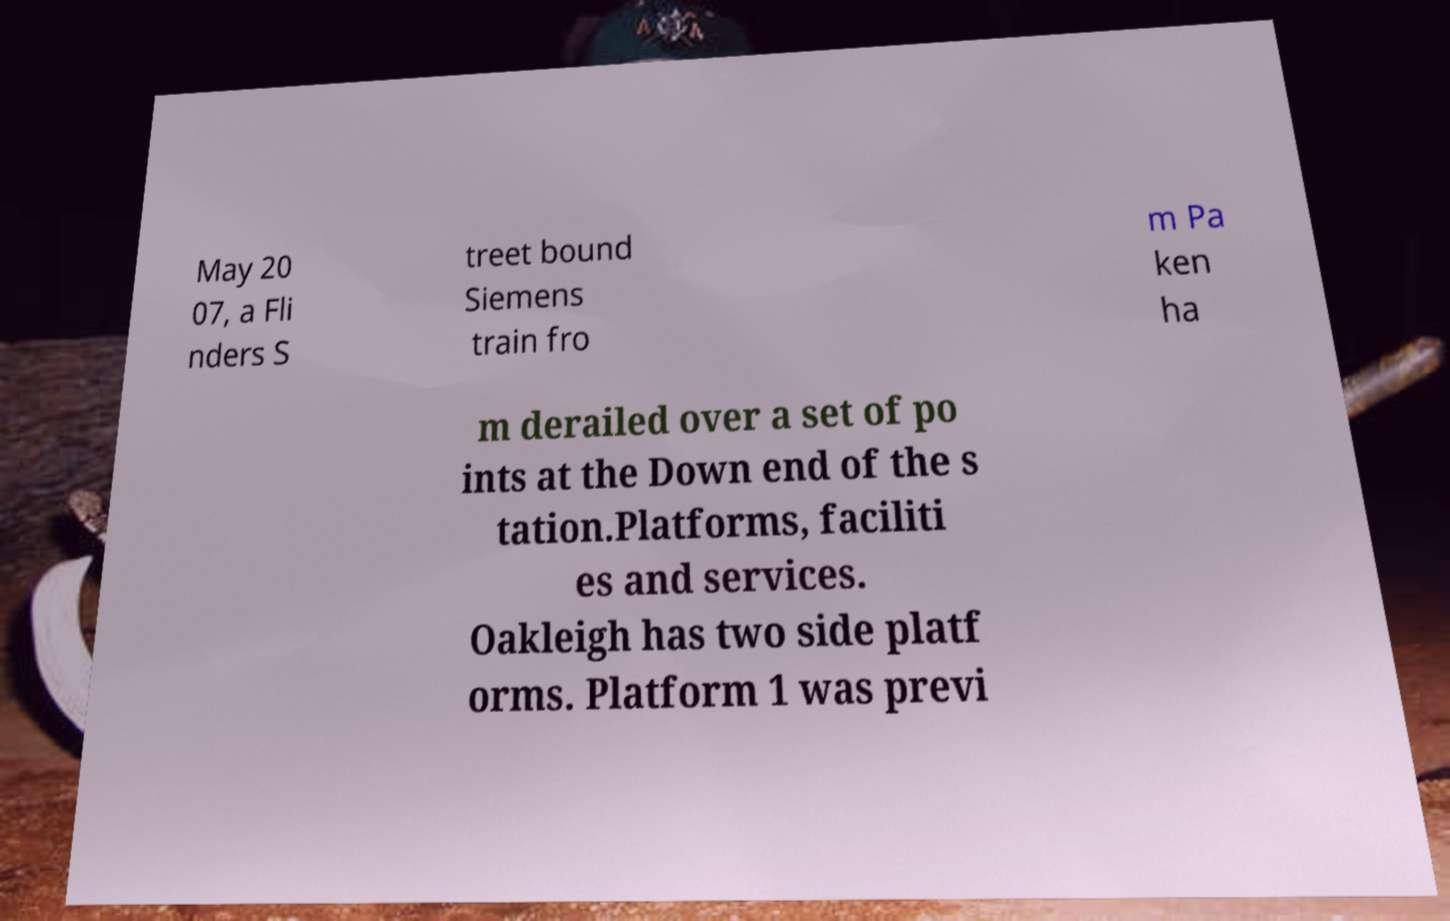There's text embedded in this image that I need extracted. Can you transcribe it verbatim? May 20 07, a Fli nders S treet bound Siemens train fro m Pa ken ha m derailed over a set of po ints at the Down end of the s tation.Platforms, faciliti es and services. Oakleigh has two side platf orms. Platform 1 was previ 